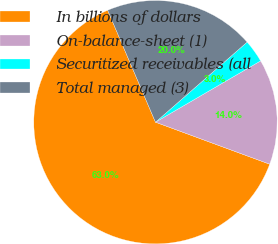Convert chart. <chart><loc_0><loc_0><loc_500><loc_500><pie_chart><fcel>In billions of dollars<fcel>On-balance-sheet (1)<fcel>Securitized receivables (all<fcel>Total managed (3)<nl><fcel>62.97%<fcel>14.01%<fcel>3.03%<fcel>20.0%<nl></chart> 